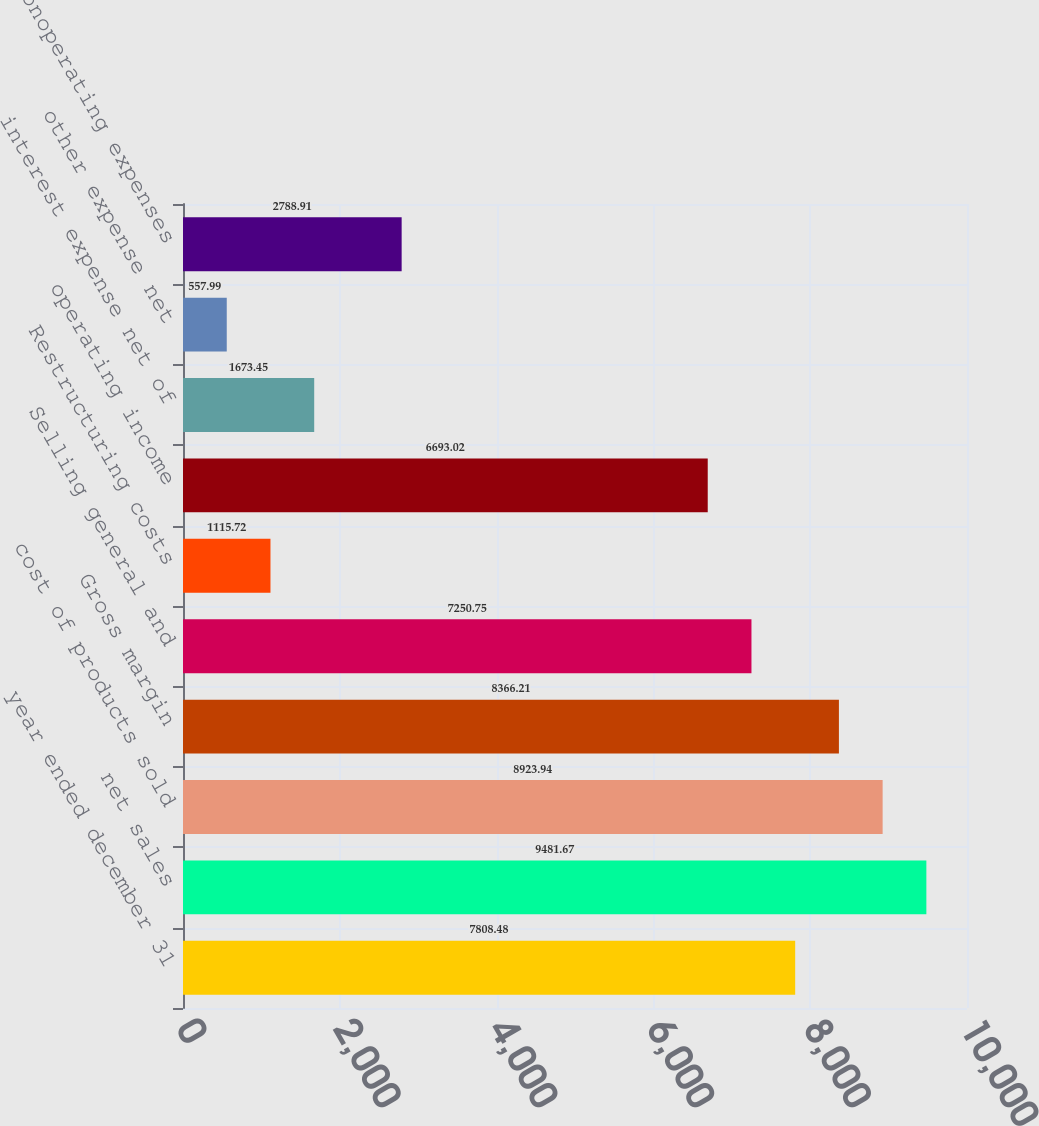<chart> <loc_0><loc_0><loc_500><loc_500><bar_chart><fcel>year ended december 31<fcel>net sales<fcel>cost of products sold<fcel>Gross margin<fcel>Selling general and<fcel>Restructuring costs<fcel>operating income<fcel>interest expense net of<fcel>other expense net<fcel>net nonoperating expenses<nl><fcel>7808.48<fcel>9481.67<fcel>8923.94<fcel>8366.21<fcel>7250.75<fcel>1115.72<fcel>6693.02<fcel>1673.45<fcel>557.99<fcel>2788.91<nl></chart> 